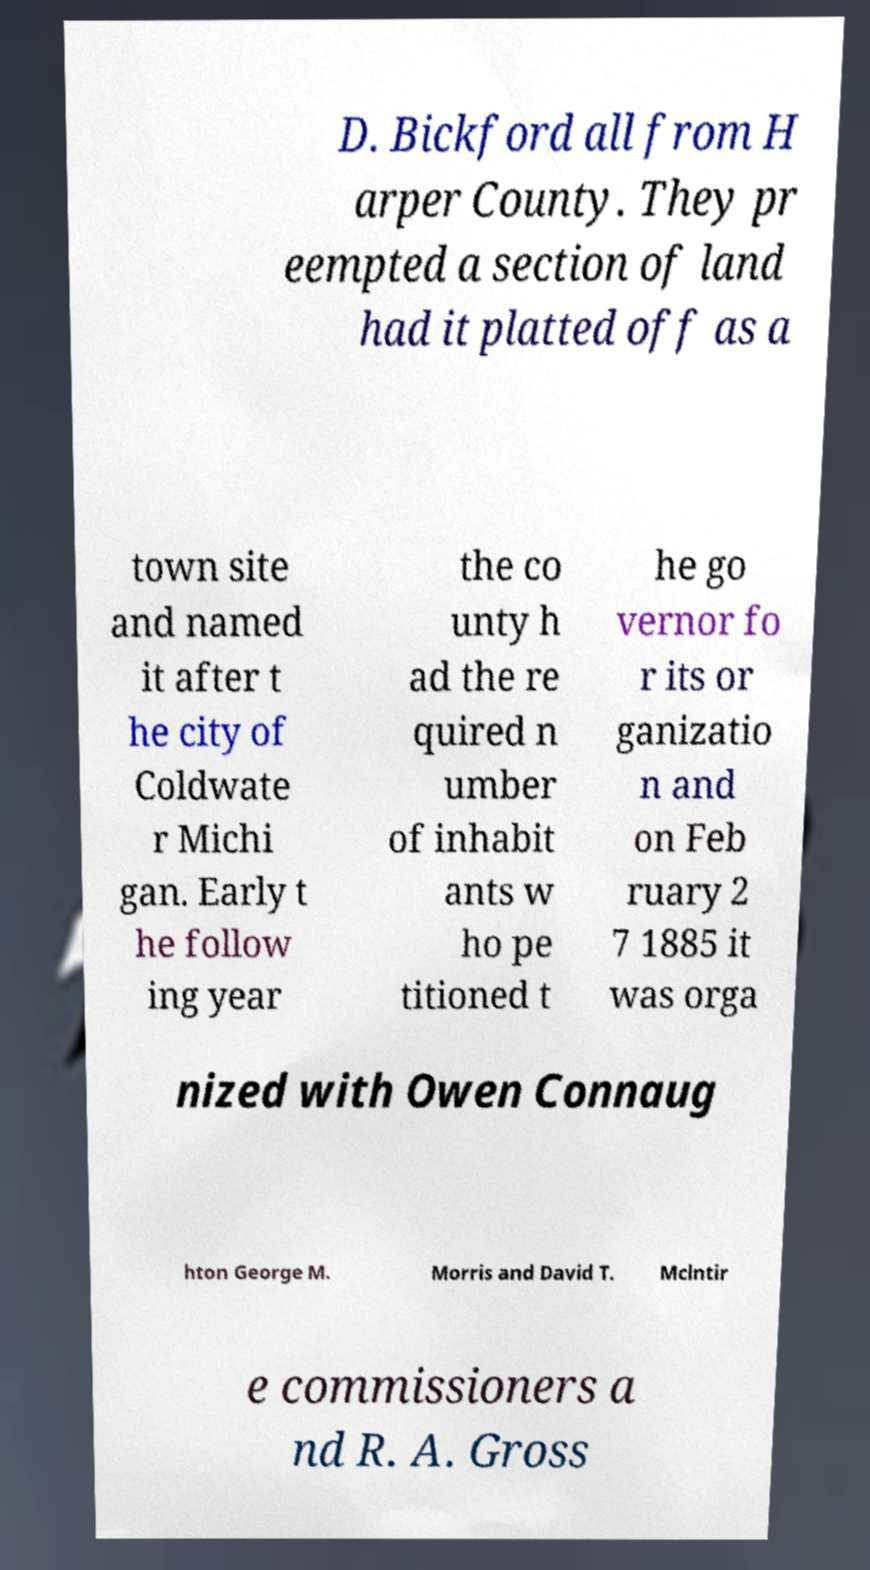For documentation purposes, I need the text within this image transcribed. Could you provide that? D. Bickford all from H arper County. They pr eempted a section of land had it platted off as a town site and named it after t he city of Coldwate r Michi gan. Early t he follow ing year the co unty h ad the re quired n umber of inhabit ants w ho pe titioned t he go vernor fo r its or ganizatio n and on Feb ruary 2 7 1885 it was orga nized with Owen Connaug hton George M. Morris and David T. Mclntir e commissioners a nd R. A. Gross 